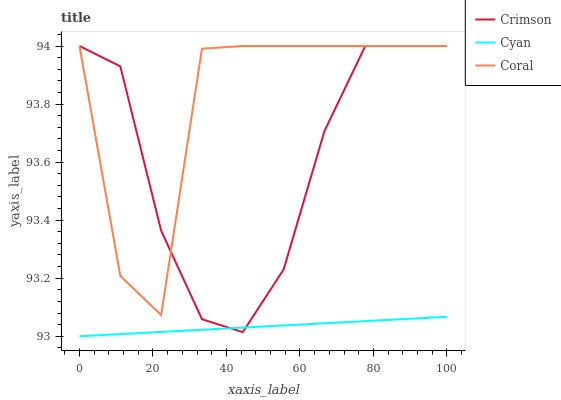Does Cyan have the minimum area under the curve?
Answer yes or no. Yes. Does Coral have the maximum area under the curve?
Answer yes or no. Yes. Does Coral have the minimum area under the curve?
Answer yes or no. No. Does Cyan have the maximum area under the curve?
Answer yes or no. No. Is Cyan the smoothest?
Answer yes or no. Yes. Is Coral the roughest?
Answer yes or no. Yes. Is Coral the smoothest?
Answer yes or no. No. Is Cyan the roughest?
Answer yes or no. No. Does Cyan have the lowest value?
Answer yes or no. Yes. Does Coral have the lowest value?
Answer yes or no. No. Does Coral have the highest value?
Answer yes or no. Yes. Does Cyan have the highest value?
Answer yes or no. No. Is Cyan less than Coral?
Answer yes or no. Yes. Is Coral greater than Cyan?
Answer yes or no. Yes. Does Crimson intersect Cyan?
Answer yes or no. Yes. Is Crimson less than Cyan?
Answer yes or no. No. Is Crimson greater than Cyan?
Answer yes or no. No. Does Cyan intersect Coral?
Answer yes or no. No. 